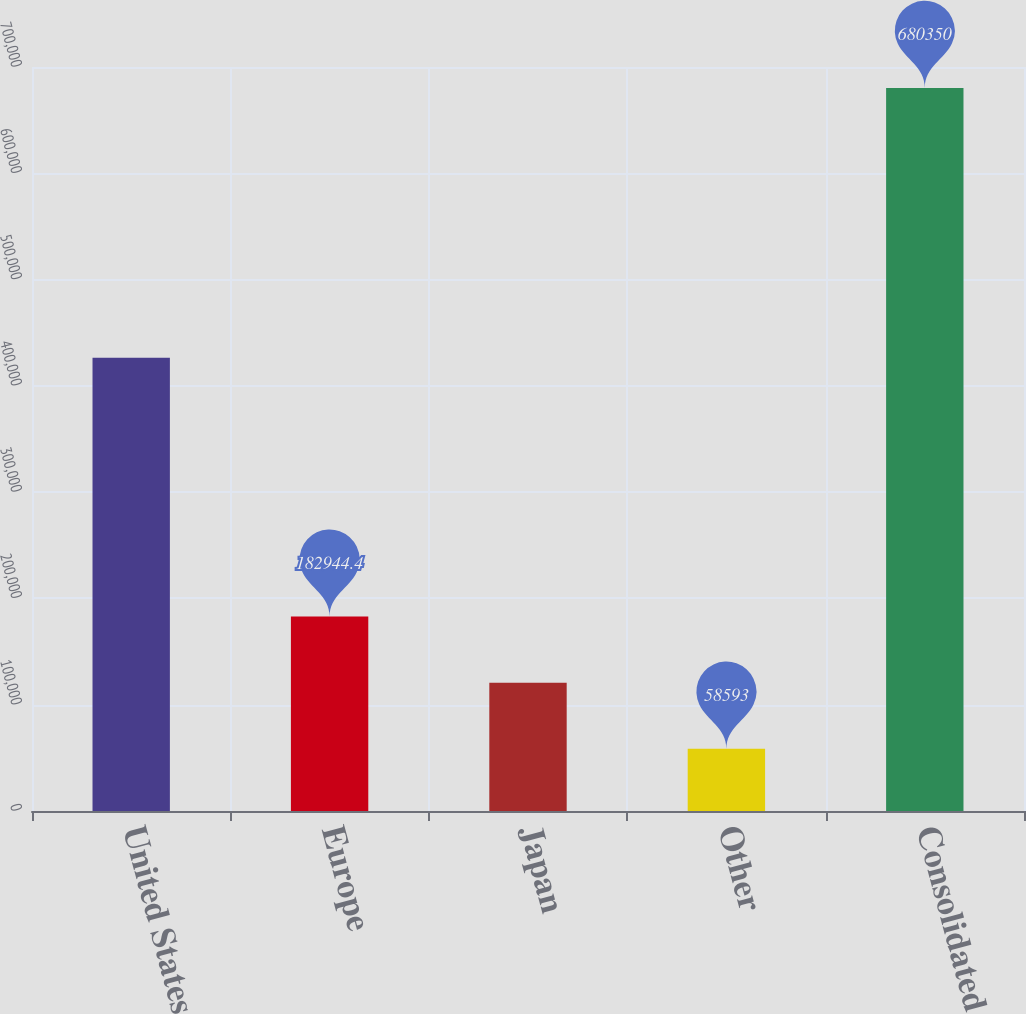<chart> <loc_0><loc_0><loc_500><loc_500><bar_chart><fcel>United States<fcel>Europe<fcel>Japan<fcel>Other<fcel>Consolidated<nl><fcel>426527<fcel>182944<fcel>120769<fcel>58593<fcel>680350<nl></chart> 